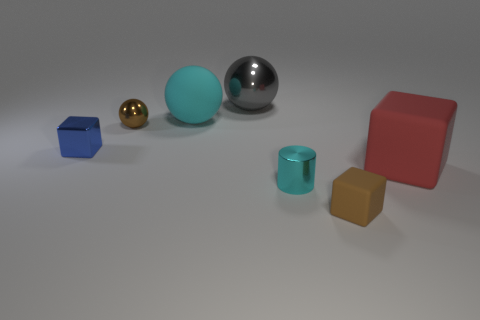The gray object that is made of the same material as the tiny blue block is what size?
Make the answer very short. Large. There is a matte cube behind the tiny cube in front of the cyan object in front of the brown metal object; what is its size?
Make the answer very short. Large. What size is the brown thing that is in front of the small brown metallic sphere?
Your answer should be compact. Small. What number of blue things are rubber cylinders or shiny cubes?
Give a very brief answer. 1. Are there any gray cylinders that have the same size as the blue metallic cube?
Ensure brevity in your answer.  No. There is a gray thing that is the same size as the cyan ball; what is its material?
Your answer should be compact. Metal. Does the block that is in front of the large matte block have the same size as the cyan thing that is in front of the big cyan object?
Give a very brief answer. Yes. What number of things are either tiny blue matte spheres or matte balls behind the small cyan shiny object?
Give a very brief answer. 1. Are there any other objects of the same shape as the blue shiny thing?
Make the answer very short. Yes. What is the size of the ball behind the matte thing that is behind the tiny metal ball?
Provide a succinct answer. Large. 